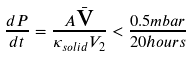Convert formula to latex. <formula><loc_0><loc_0><loc_500><loc_500>\frac { d P } { d t } = \frac { A \bar { \text  v}}{\kappa_{solid} V_{2}} < \frac{0.5 mbar}{20 hours}</formula> 